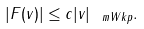Convert formula to latex. <formula><loc_0><loc_0><loc_500><loc_500>| F ( v ) | \leq c | v | _ { \ m { W k p } } .</formula> 